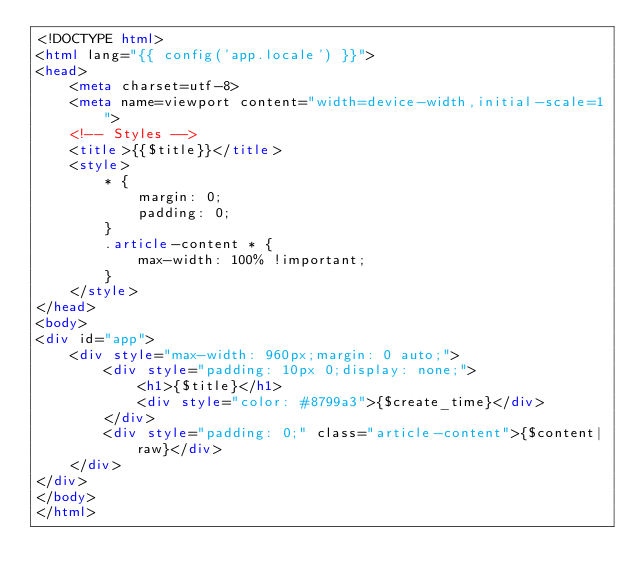Convert code to text. <code><loc_0><loc_0><loc_500><loc_500><_HTML_><!DOCTYPE html>
<html lang="{{ config('app.locale') }}">
<head>
    <meta charset=utf-8>
    <meta name=viewport content="width=device-width,initial-scale=1">
    <!-- Styles -->
    <title>{{$title}}</title>
    <style>
        * {
            margin: 0;
            padding: 0;
        }
        .article-content * {
            max-width: 100% !important;
        }
    </style>
</head>
<body>
<div id="app">
    <div style="max-width: 960px;margin: 0 auto;">
        <div style="padding: 10px 0;display: none;">
            <h1>{$title}</h1>
            <div style="color: #8799a3">{$create_time}</div>
        </div>
        <div style="padding: 0;" class="article-content">{$content|raw}</div>
    </div>
</div>
</body>
</html>
</code> 